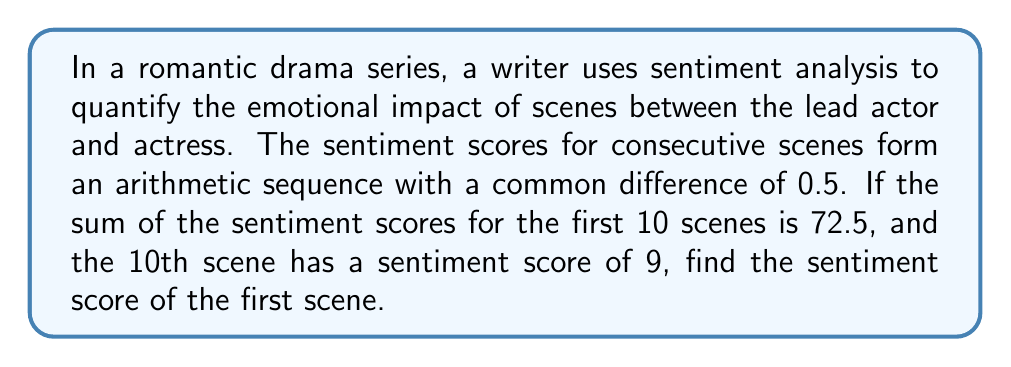Provide a solution to this math problem. Let's approach this step-by-step:

1) Let $a$ be the first term (sentiment score of the first scene) and $d$ be the common difference.
   We're given that $d = 0.5$.

2) For an arithmetic sequence, the nth term is given by:
   $a_n = a + (n-1)d$

3) We're told that the 10th term $a_{10} = 9$. Let's use this:
   $9 = a + (10-1)0.5$
   $9 = a + 4.5$
   $a = 4.5$

4) Now, let's verify this using the sum formula. The sum of an arithmetic sequence is given by:
   $S_n = \frac{n}{2}(a_1 + a_n) = \frac{n}{2}(2a_1 + (n-1)d)$

5) We're given that the sum of the first 10 terms is 72.5:
   $72.5 = \frac{10}{2}(2a + (10-1)0.5)$
   $72.5 = 5(2a + 4.5)$
   $14.5 = 2a + 4.5$
   $10 = 2a$
   $a = 5$

6) We've arrived at two different values for $a$. This means our initial assumption that the first term is 4.5 was incorrect.

7) Let's use the correct value of $a = 5$ in the sequence:
   $a_1 = 5$
   $a_2 = 5.5$
   $a_3 = 6$
   ...
   $a_{10} = 9.5$

8) We can verify that this sequence sums to 72.5:
   $S_{10} = \frac{10}{2}(5 + 9.5) = 5(14.5) = 72.5$

Therefore, the sentiment score of the first scene is 5.
Answer: 5 